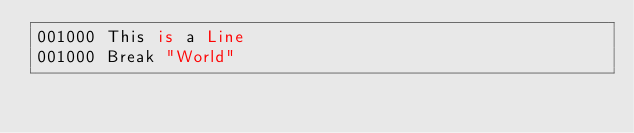Convert code to text. <code><loc_0><loc_0><loc_500><loc_500><_COBOL_>001000 This is a Line 
001000 Break "World"</code> 